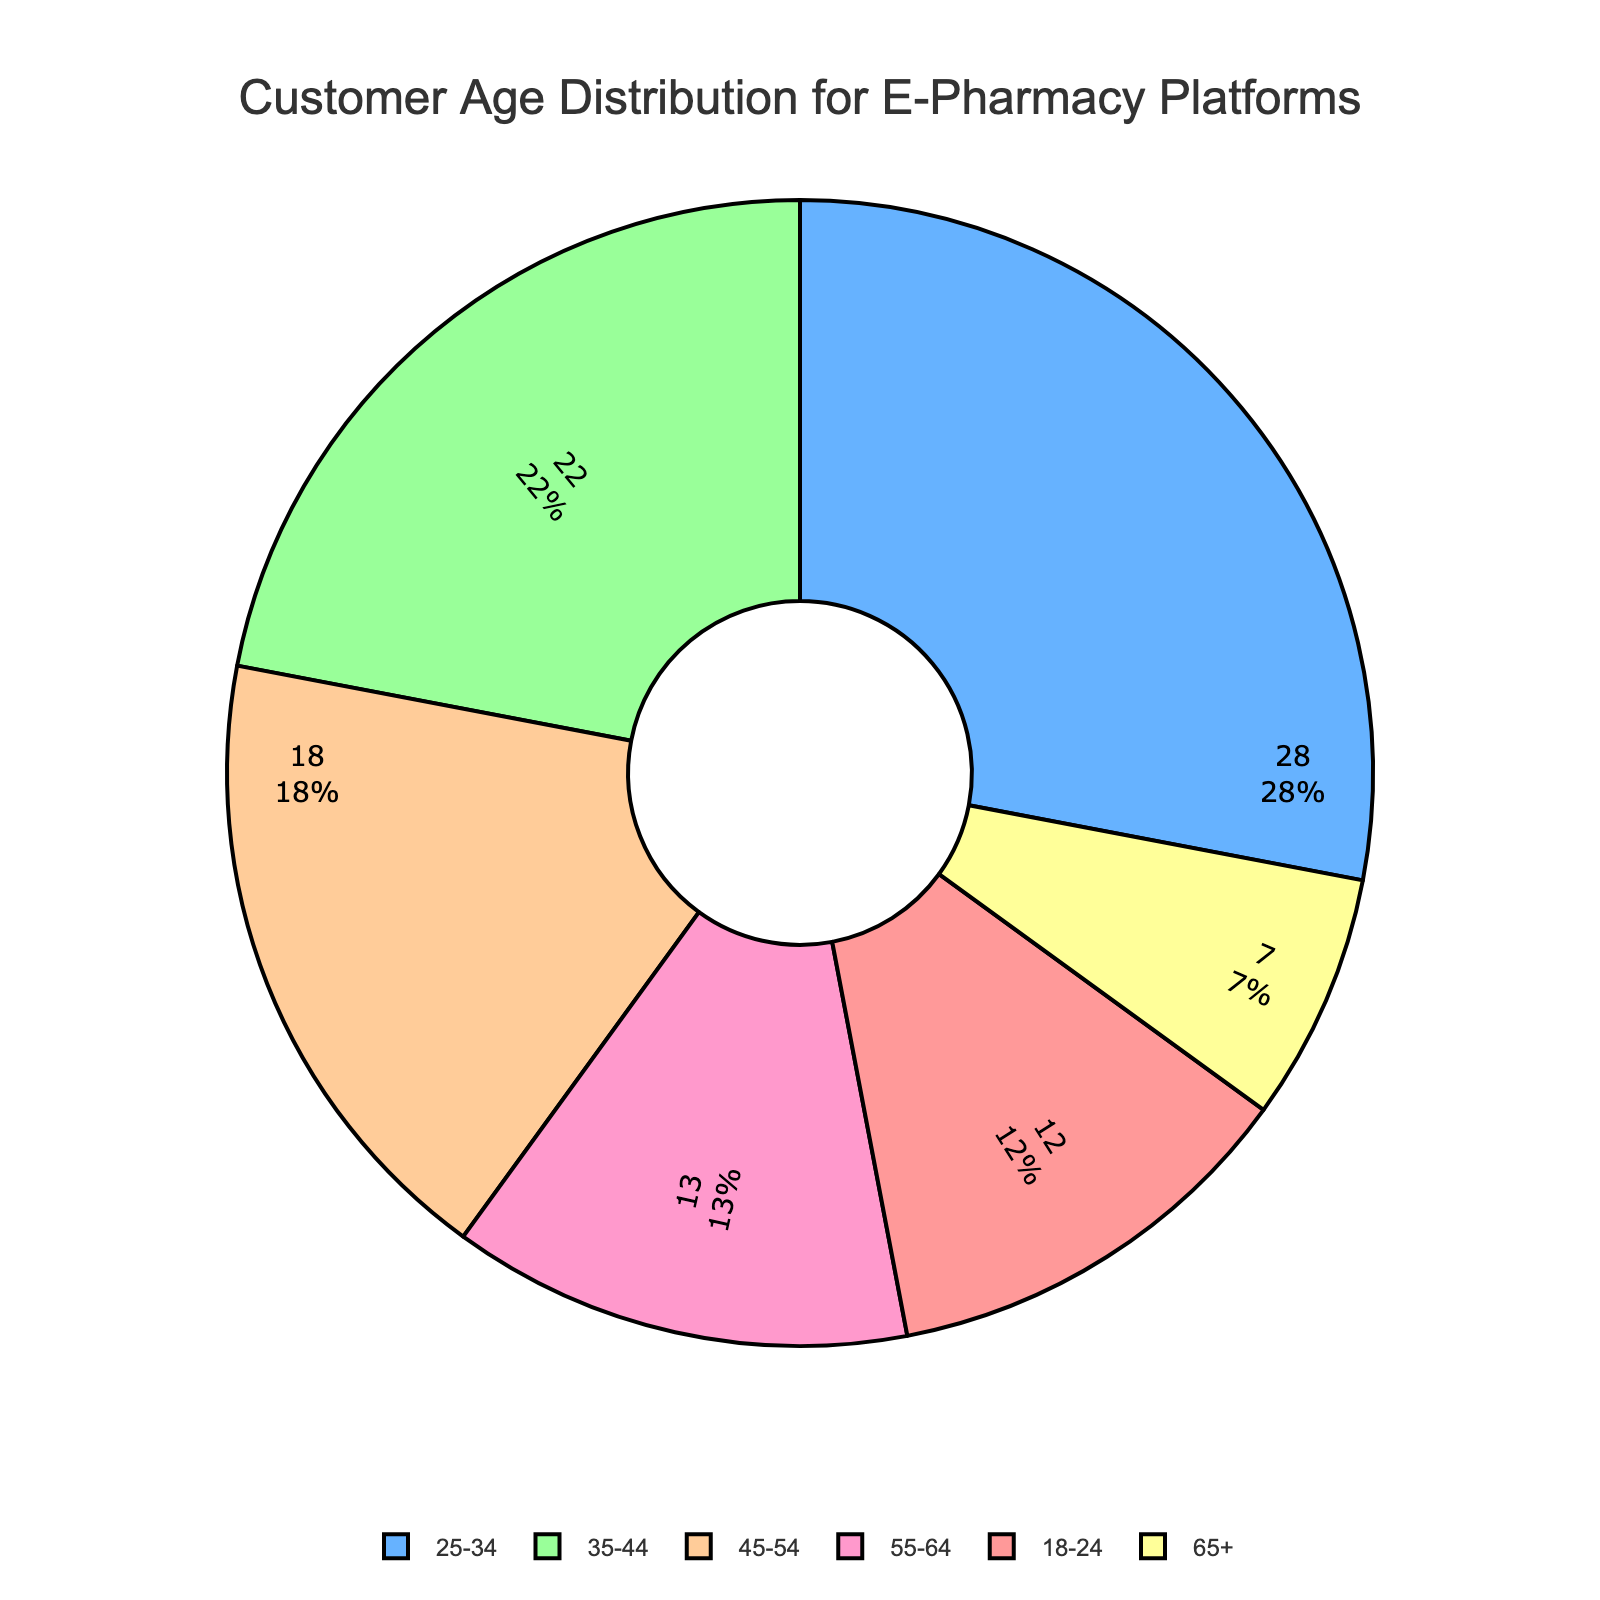What's the percentage of customers aged 25-44? Add the percentages of the 25-34 and 35-44 age groups: 28% + 22% = 50%
Answer: 50% What is the difference in customer percentage between the 18-24 and 65+ age groups? Subtract the percentage of the 65+ age group from the 18-24 age group: 12% - 7% = 5%
Answer: 5% Which age group has the second highest percentage of customers? Compare the percentages of all age groups and find the second highest: 28% (25-34) is the highest, and 22% (35-44) is the second highest
Answer: 35-44 What combined percentage of customers are there in the age groups above 45? Add the percentages of 45-54, 55-64, and 65+ age groups: 18% + 13% + 7% = 38%
Answer: 38% Which age group contributes the smallest percentage of customers? Identify the age group with the smallest percentage: 65+ with 7%
Answer: 65+ What is the sum of the percentages of the 45-54 and 55-64 age groups? Add the percentages of the 45-54 and 55-64 age groups: 18% + 13% = 31%
Answer: 31% Which color is used to represent the 25-34 age group? The figure uses blue to represent the 25-34 age group
Answer: Blue Is the percentage of customers aged under 35 greater than those aged 55 and above? Calculate the combined percentage of customers under 35: 12% + 28% = 40%; for 55 and above: 13% + 7% = 20%; Compare the two values: 40% > 20%
Answer: Yes 